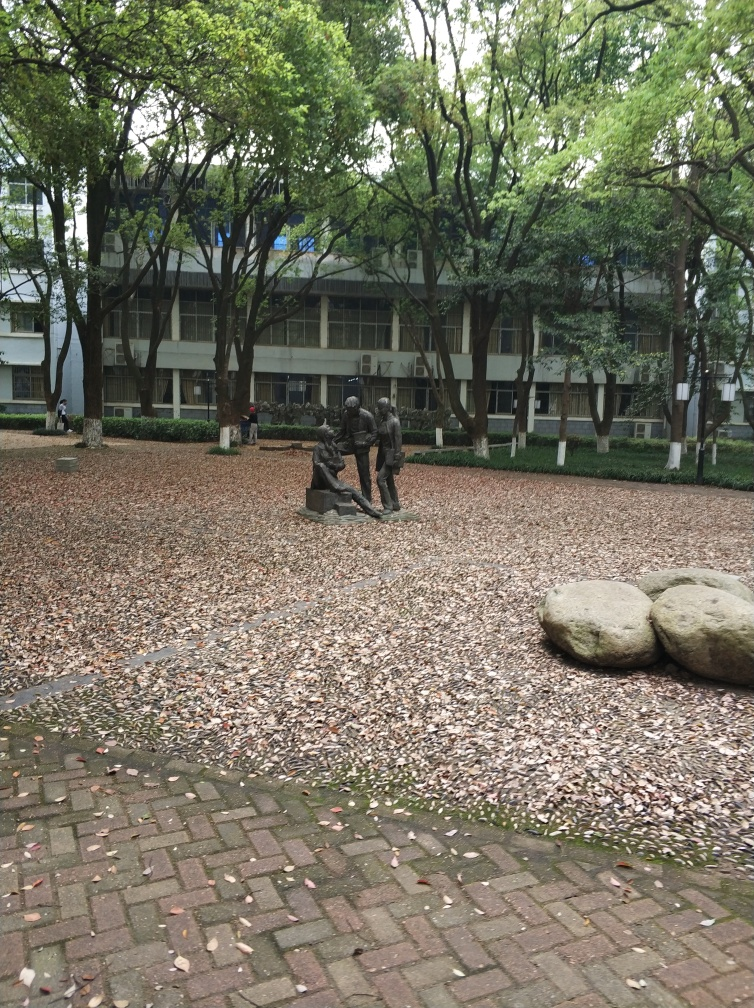What could be the significance of the rocks in the foreground? The rocks in the foreground contribute to the natural landscape of the scene, potentially serving as a deliberate element of the outdoor design. They offer a contrast in texture and color against the brick path and fallen leaves, thereby enhancing the aesthetic appeal of the setting. It's possible they also serve a practical purpose, such as preventing erosion or demarcating an area. 